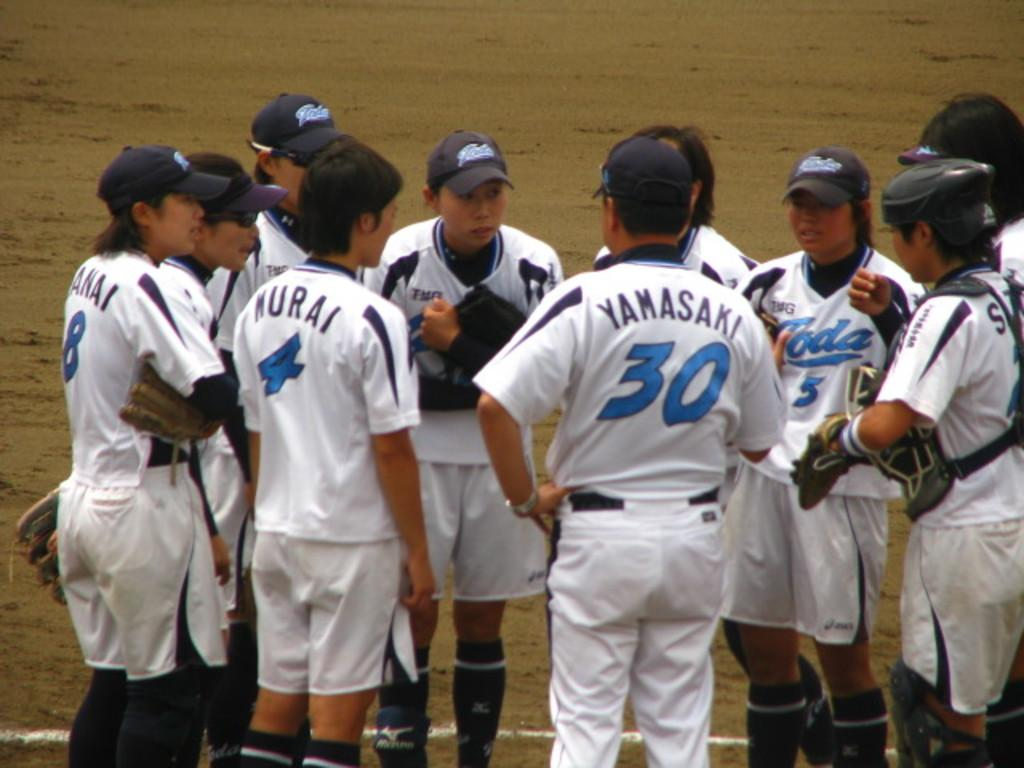<image>
Summarize the visual content of the image. Player wearing number 30 is standing in a team huddle. 